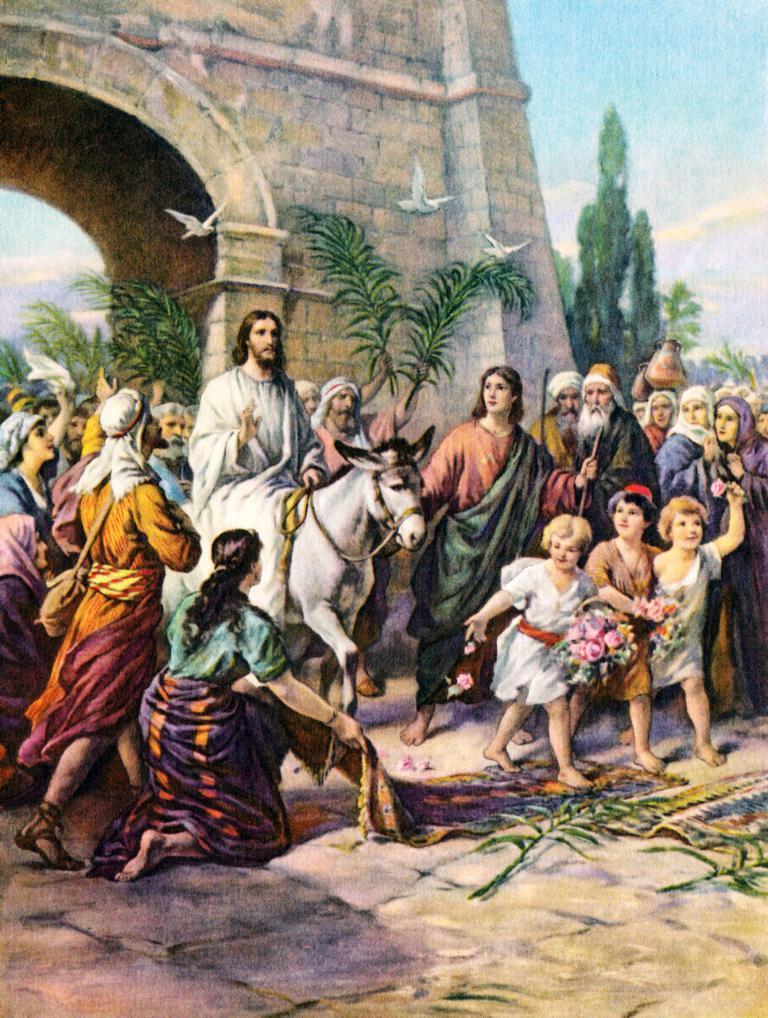In one or two sentences, can you explain what this image depicts? In this image, we can see a poster. Here we can see a group of people. Few are walking and standing. Here a person is riding a horse. Background we can see a wall, trees, birds and sky. 